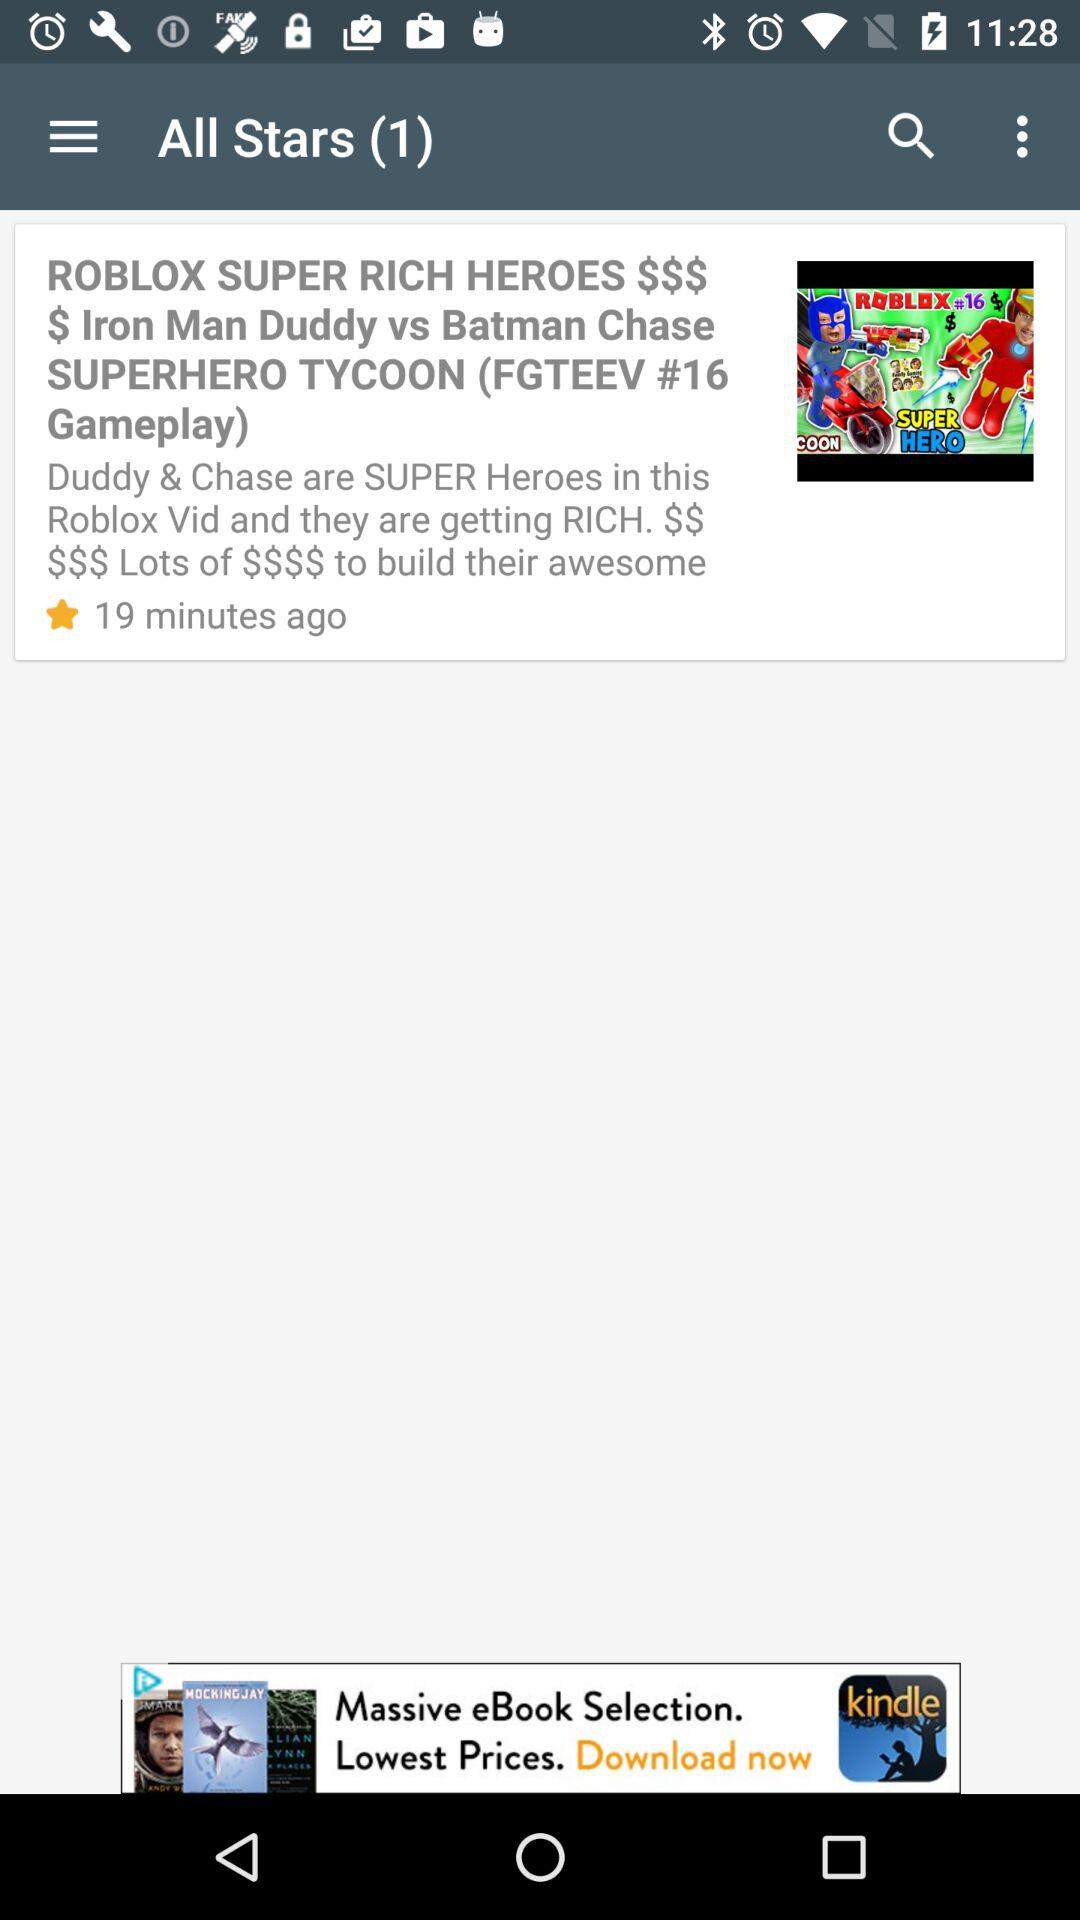How many minutes ago was the video uploaded?
Answer the question using a single word or phrase. 19 